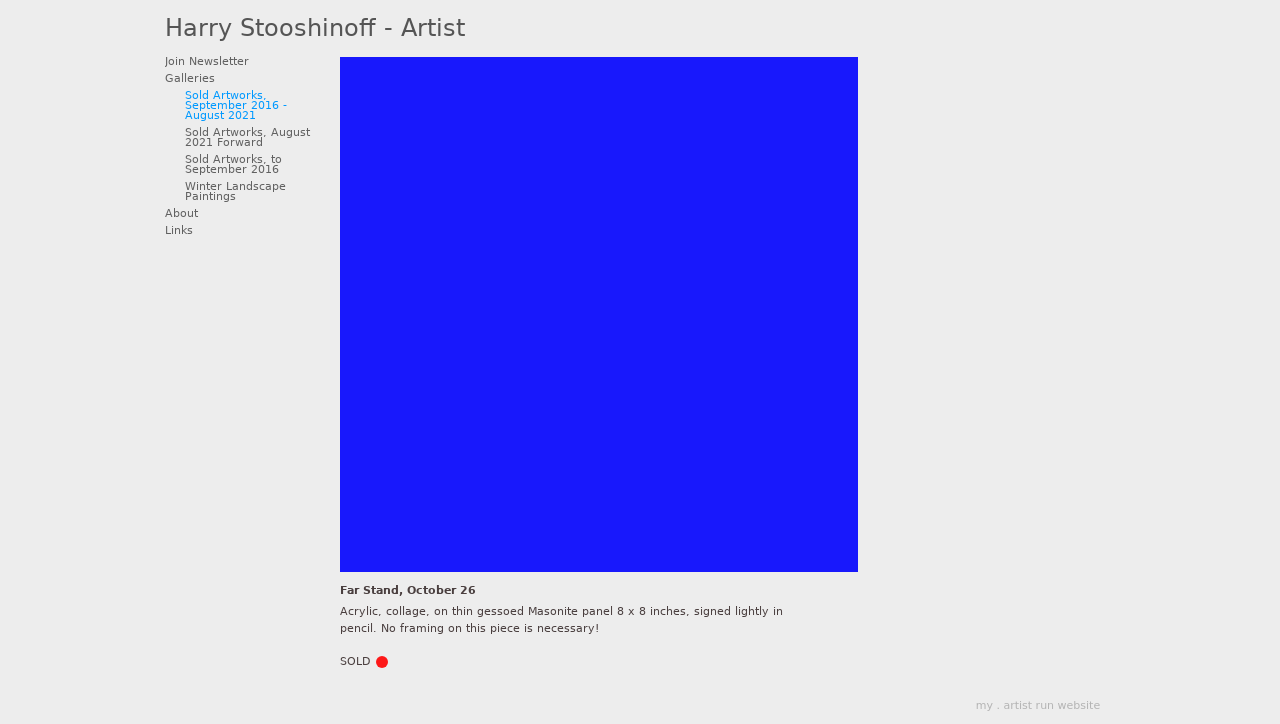What inspired the artist to create 'Far Stand, October 26'? Harry Stooshinoff draws inspiration from the rural landscapes around him. His daily walks and the changing seasons greatly influence his work, as seen in 'Far Stand, October 26'. The piece likely captures a specific scenic moment or emotion experienced on one of these days in late October, rendered abstractly through his signature style and use of mixed media.  Could you elaborate on how the artwork is structured in terms of composition and color? In 'Far Stand, October 26', Stooshinoff employs a balanced composition with thoughtful placement of colors and shapes to lead the viewer's eye across the canvas. The colors are seasonally appropriate, likely featuring autumnal hues that convey the atmosphere of an October day. He uses contrast effectively, highlighting certain elements with brighter or darker colors to create depth and movement within the flat surface of the Masonite panel. 